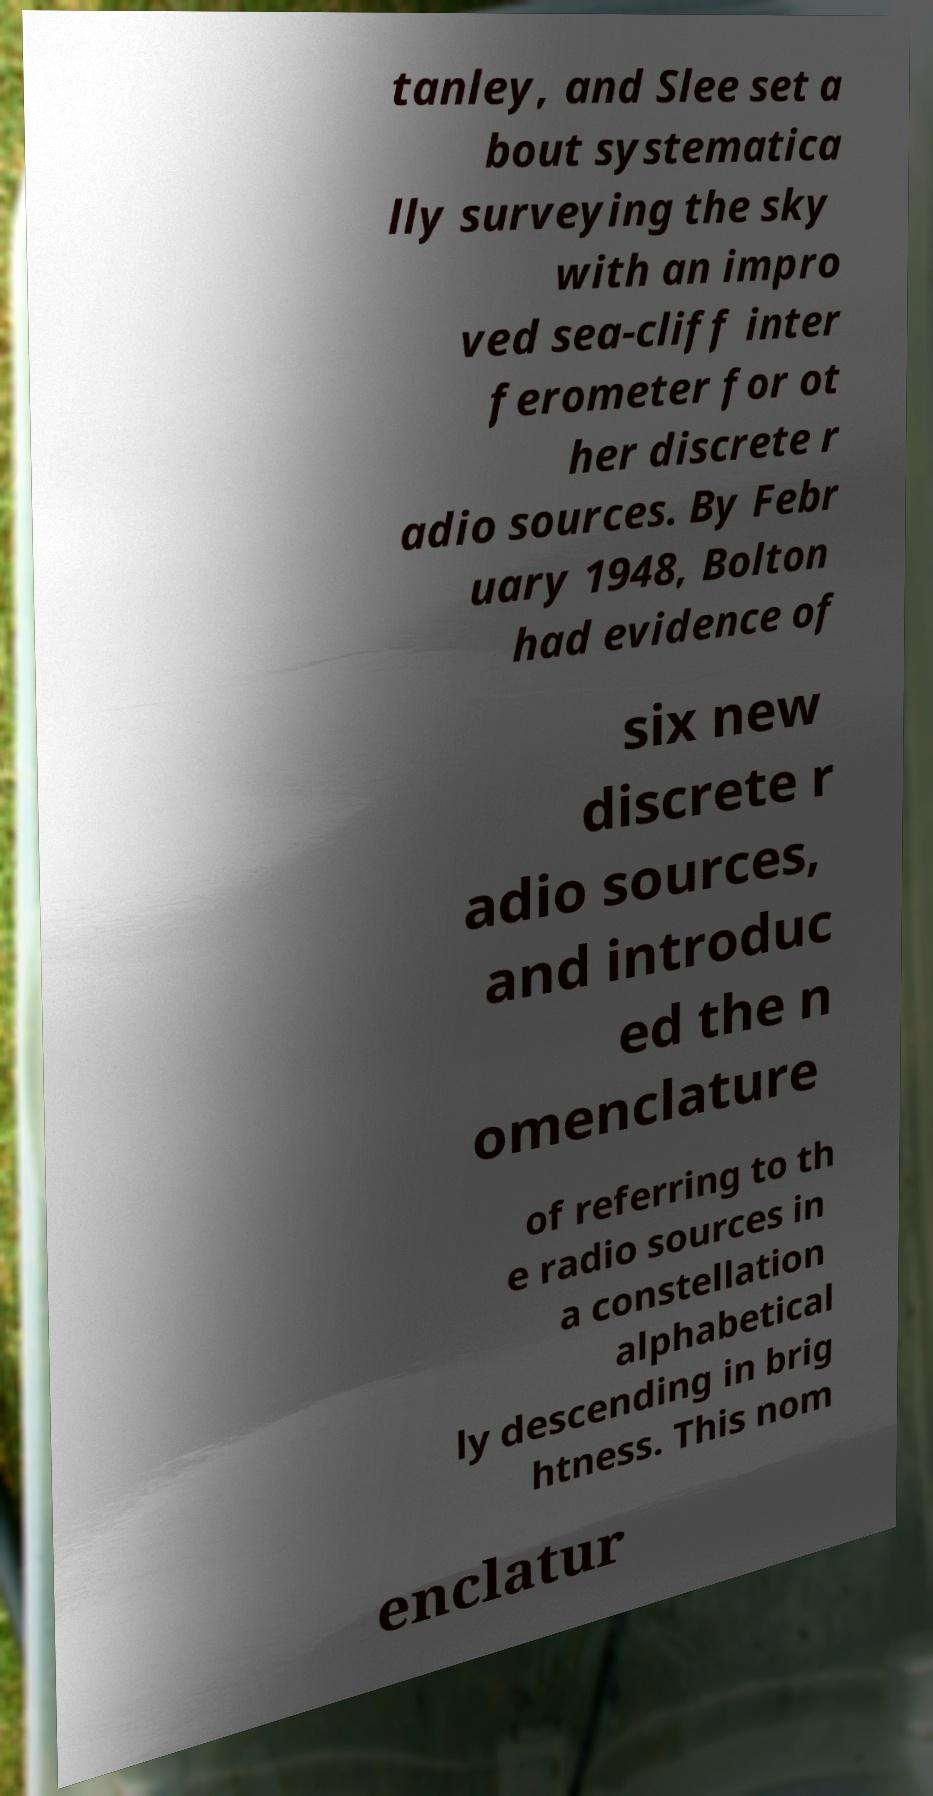Please read and relay the text visible in this image. What does it say? tanley, and Slee set a bout systematica lly surveying the sky with an impro ved sea-cliff inter ferometer for ot her discrete r adio sources. By Febr uary 1948, Bolton had evidence of six new discrete r adio sources, and introduc ed the n omenclature of referring to th e radio sources in a constellation alphabetical ly descending in brig htness. This nom enclatur 